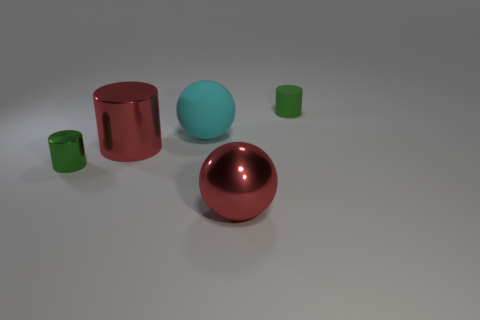Are there an equal number of tiny matte objects to the left of the big red metal cylinder and tiny green objects?
Make the answer very short. No. How many brown things are the same shape as the green metal thing?
Provide a succinct answer. 0. Does the green matte thing have the same shape as the tiny metal thing?
Make the answer very short. Yes. What number of things are red things that are in front of the big metal cylinder or tiny brown shiny balls?
Your response must be concise. 1. There is a rubber object in front of the matte thing on the right side of the large red object in front of the small green metal object; what shape is it?
Offer a very short reply. Sphere. There is a large thing that is made of the same material as the red cylinder; what shape is it?
Offer a very short reply. Sphere. How big is the cyan matte sphere?
Ensure brevity in your answer.  Large. Do the cyan sphere and the red cylinder have the same size?
Make the answer very short. Yes. How many things are large red spheres to the right of the big matte object or things that are to the right of the green metallic cylinder?
Ensure brevity in your answer.  4. There is a green thing that is right of the tiny cylinder that is in front of the tiny rubber thing; what number of big cyan matte things are in front of it?
Ensure brevity in your answer.  1. 